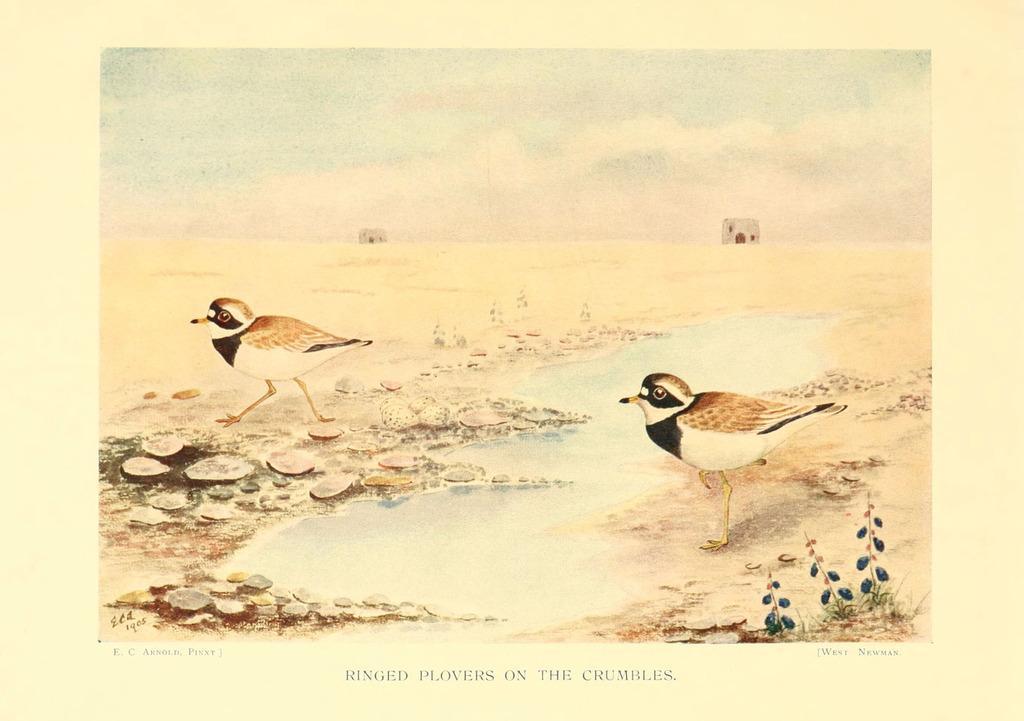In one or two sentences, can you explain what this image depicts? This picture is a painting on the paper. In the image, on the right side and left side, we can see painting of two birds standing on the land, we can also see rocks. In this painting, we can also see houses and a sky. 